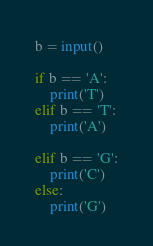<code> <loc_0><loc_0><loc_500><loc_500><_Python_>b = input()

if b == 'A':
    print('T')
elif b == 'T':
    print('A')
    
elif b == 'G':
    print('C')
else:
    print('G')</code> 